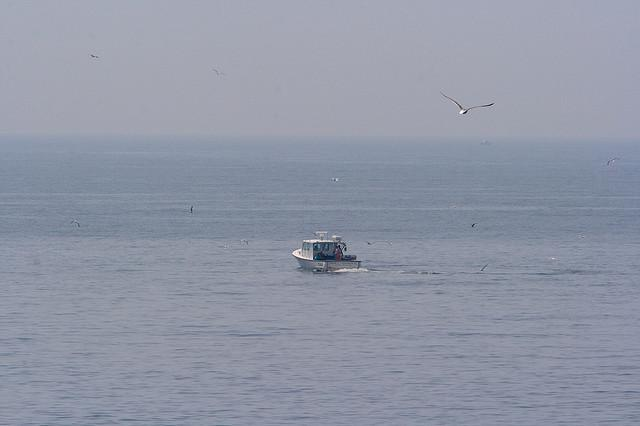What is the name of the object on top of the boat's roof?

Choices:
A) radio
B) booster
C) radar
D) antenna antenna 